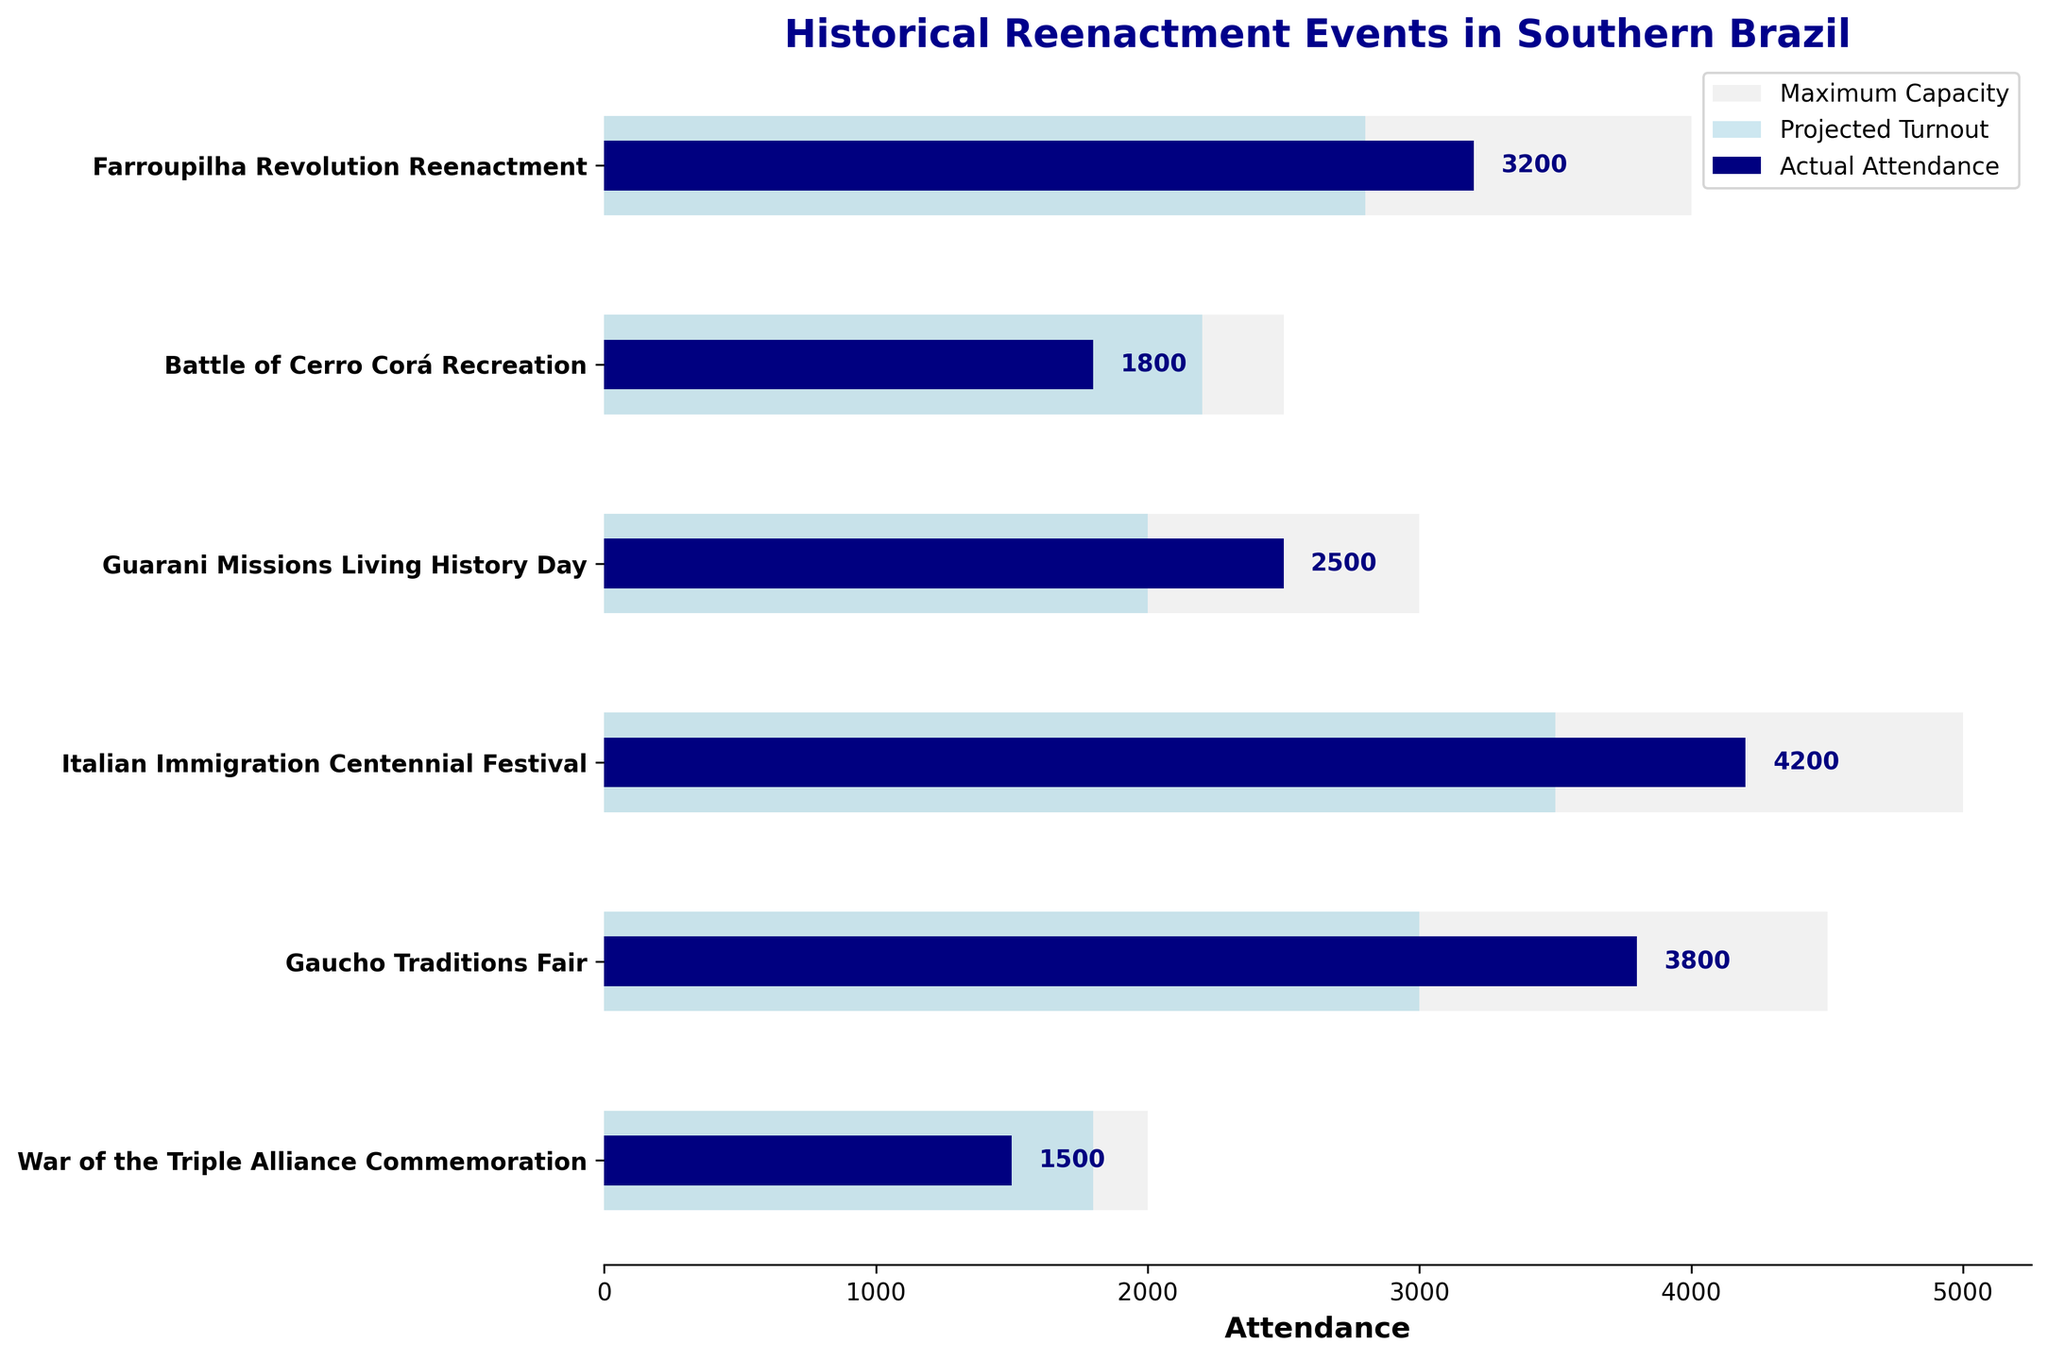What's the title of the figure? Look at the top of the chart where the title is displayed.
Answer: Historical Reenactment Events in Southern Brazil What is the color used to represent the maximum capacity? Identify the largest horizontal bars in the figure and observe their color.
Answer: Light grey What event had the highest actual attendance? Examine the actual attendance bars and find the one with the greatest length.
Answer: Italian Immigration Centennial Festival How does the actual attendance for the Farroupilha Revolution Reenactment compare to its projected turnout? Check the lengths of the actual attendance and projected turnout bars for the Farroupilha Revolution Reenactment.
Answer: The actual attendance was higher than the projected turnout For the Gaucho Traditions Fair, how many more people attended than the projected turnout? Subtract the projected turnout from the actual attendance for the Gaucho Traditions Fair.
Answer: 800 Which event had the lowest actual attendance, and what was the value? Look for the smallest actual attendance bar and note the event and its value.
Answer: War of the Triple Alliance Commemoration, 1500 Calculate the average projected turnout for all events. Add up all the projected turnout numbers and divide by the number of events. (2800 + 2200 + 2000 + 3500 + 3000 + 1800) / 6
Answer: 2550 Which event has a projected turnout closest to its maximum capacity? Subtract the projected turnout from the maximum capacity for each event and find the smallest difference.
Answer: Battle of Cerro Corá Recreation How much higher was the actual attendance than maximum capacity for the event with the highest excess? Find events where the actual attendance exceeds the maximum capacity, calculate the differences, and identify the highest one.
Answer: No event exceeded its maximum capacity By how much did the actual attendance for the War of the Triple Alliance Commemoration fall short of its maximum capacity? Subtract the actual attendance from the maximum capacity for the War of the Triple Alliance Commemoration event.
Answer: 500 